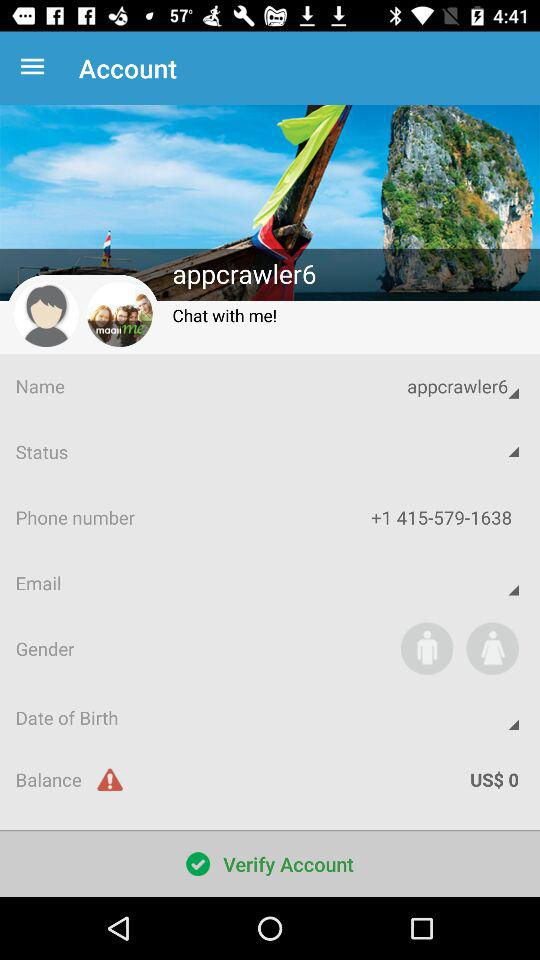What is the balance in the account? The balance in the account is 0. 